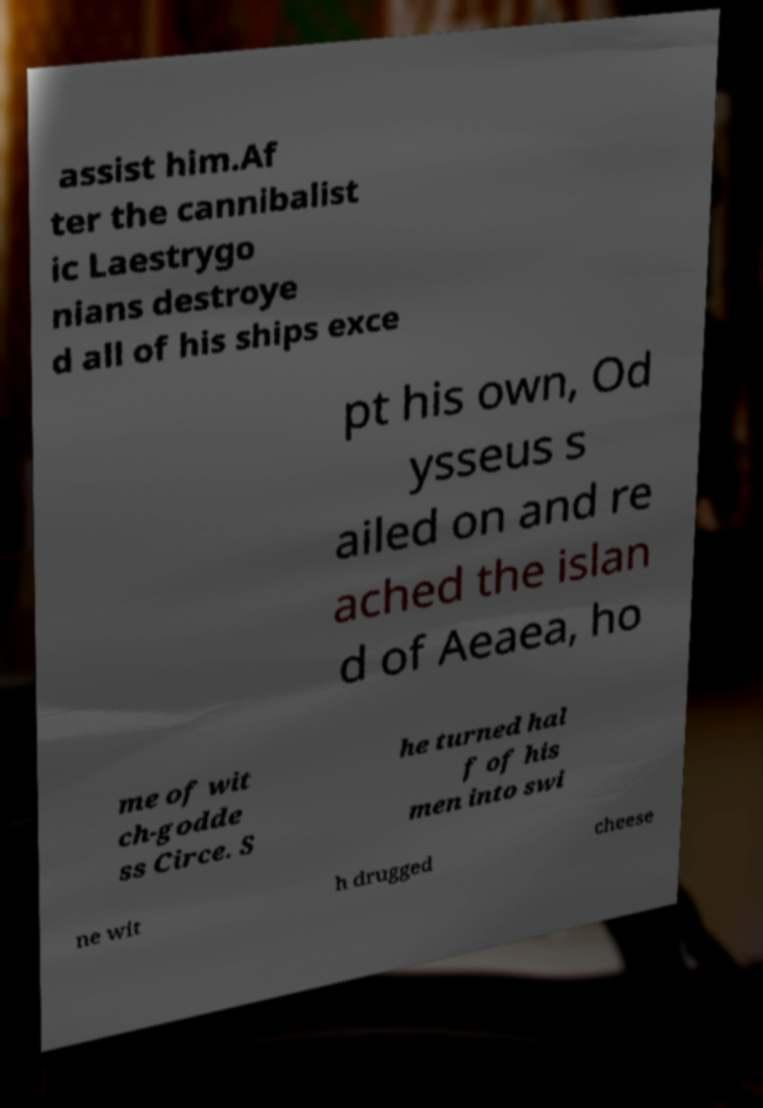Can you accurately transcribe the text from the provided image for me? assist him.Af ter the cannibalist ic Laestrygo nians destroye d all of his ships exce pt his own, Od ysseus s ailed on and re ached the islan d of Aeaea, ho me of wit ch-godde ss Circe. S he turned hal f of his men into swi ne wit h drugged cheese 